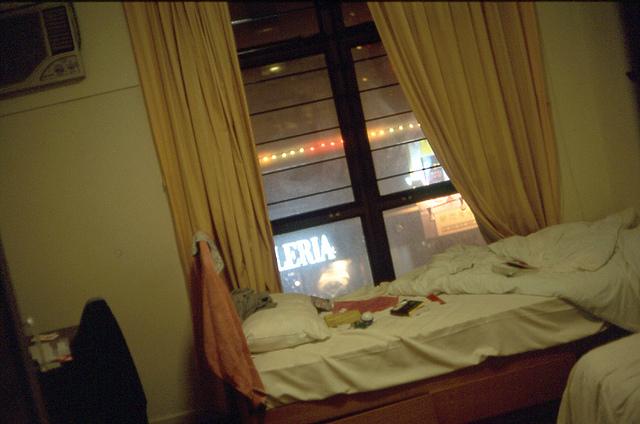What color is the window curtains?
Quick response, please. Yellow. Is there a furnace under the curtain?
Short answer required. No. How many pillows are on the bed?
Write a very short answer. 1. What is the color of the window curtains?
Keep it brief. Yellow. Is it night time?
Keep it brief. Yes. Is there a tree outside the window?
Keep it brief. No. How many pillows are there?
Quick response, please. 1. How large is the bed?
Write a very short answer. Twin. What color is the bedspread?
Concise answer only. White. Are those windows?
Be succinct. Yes. What time of day is it?
Write a very short answer. Night. What room is this?
Short answer required. Bedroom. Is this a male or woman's room?
Quick response, please. Woman. Is it daylight?
Be succinct. No. How many dolls are on the bed?
Write a very short answer. 0. Are there curtains on this window?
Concise answer only. Yes. What type of blind is over the window?
Be succinct. Mini. Is someone in bed?
Write a very short answer. No. What type of bed does this appear to be?
Be succinct. Twin. What can you see through the middle window?
Short answer required. Lights. What do you call the item directly under the window?
Write a very short answer. Bed. What kind of window covering is shown?
Be succinct. Curtains. Is the bed mattress laying down?
Quick response, please. Yes. Does this room look neat?
Be succinct. No. Is the bed made?
Give a very brief answer. No. Is the sun shining into the room?
Quick response, please. No. What kind of window treatments are featured here?
Quick response, please. Curtains. What built-in appliance is shown in the upper-left corner?
Concise answer only. Air conditioner. What colors are the curtains?
Quick response, please. Yellow. What color is the curtain?
Concise answer only. Yellow. Is this bed made?
Concise answer only. No. What pattern are the curtains?
Give a very brief answer. Solid. Is it nighttime?
Keep it brief. Yes. Is the light bright?
Give a very brief answer. No. What pattern is on the quilt?
Keep it brief. None. Is there a satellite dish visible?
Concise answer only. No. 